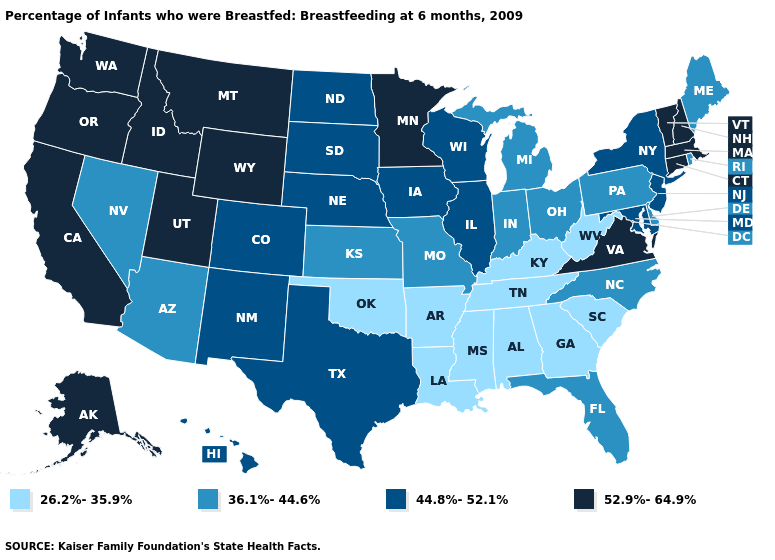What is the value of Kansas?
Answer briefly. 36.1%-44.6%. Which states have the highest value in the USA?
Concise answer only. Alaska, California, Connecticut, Idaho, Massachusetts, Minnesota, Montana, New Hampshire, Oregon, Utah, Vermont, Virginia, Washington, Wyoming. Name the states that have a value in the range 26.2%-35.9%?
Give a very brief answer. Alabama, Arkansas, Georgia, Kentucky, Louisiana, Mississippi, Oklahoma, South Carolina, Tennessee, West Virginia. What is the value of Louisiana?
Give a very brief answer. 26.2%-35.9%. What is the value of Minnesota?
Write a very short answer. 52.9%-64.9%. What is the lowest value in the South?
Write a very short answer. 26.2%-35.9%. What is the value of South Carolina?
Keep it brief. 26.2%-35.9%. Among the states that border California , which have the highest value?
Write a very short answer. Oregon. Is the legend a continuous bar?
Keep it brief. No. Does the first symbol in the legend represent the smallest category?
Write a very short answer. Yes. Name the states that have a value in the range 26.2%-35.9%?
Short answer required. Alabama, Arkansas, Georgia, Kentucky, Louisiana, Mississippi, Oklahoma, South Carolina, Tennessee, West Virginia. Name the states that have a value in the range 36.1%-44.6%?
Answer briefly. Arizona, Delaware, Florida, Indiana, Kansas, Maine, Michigan, Missouri, Nevada, North Carolina, Ohio, Pennsylvania, Rhode Island. What is the highest value in states that border Louisiana?
Concise answer only. 44.8%-52.1%. What is the value of Nevada?
Keep it brief. 36.1%-44.6%. What is the value of New Mexico?
Write a very short answer. 44.8%-52.1%. 